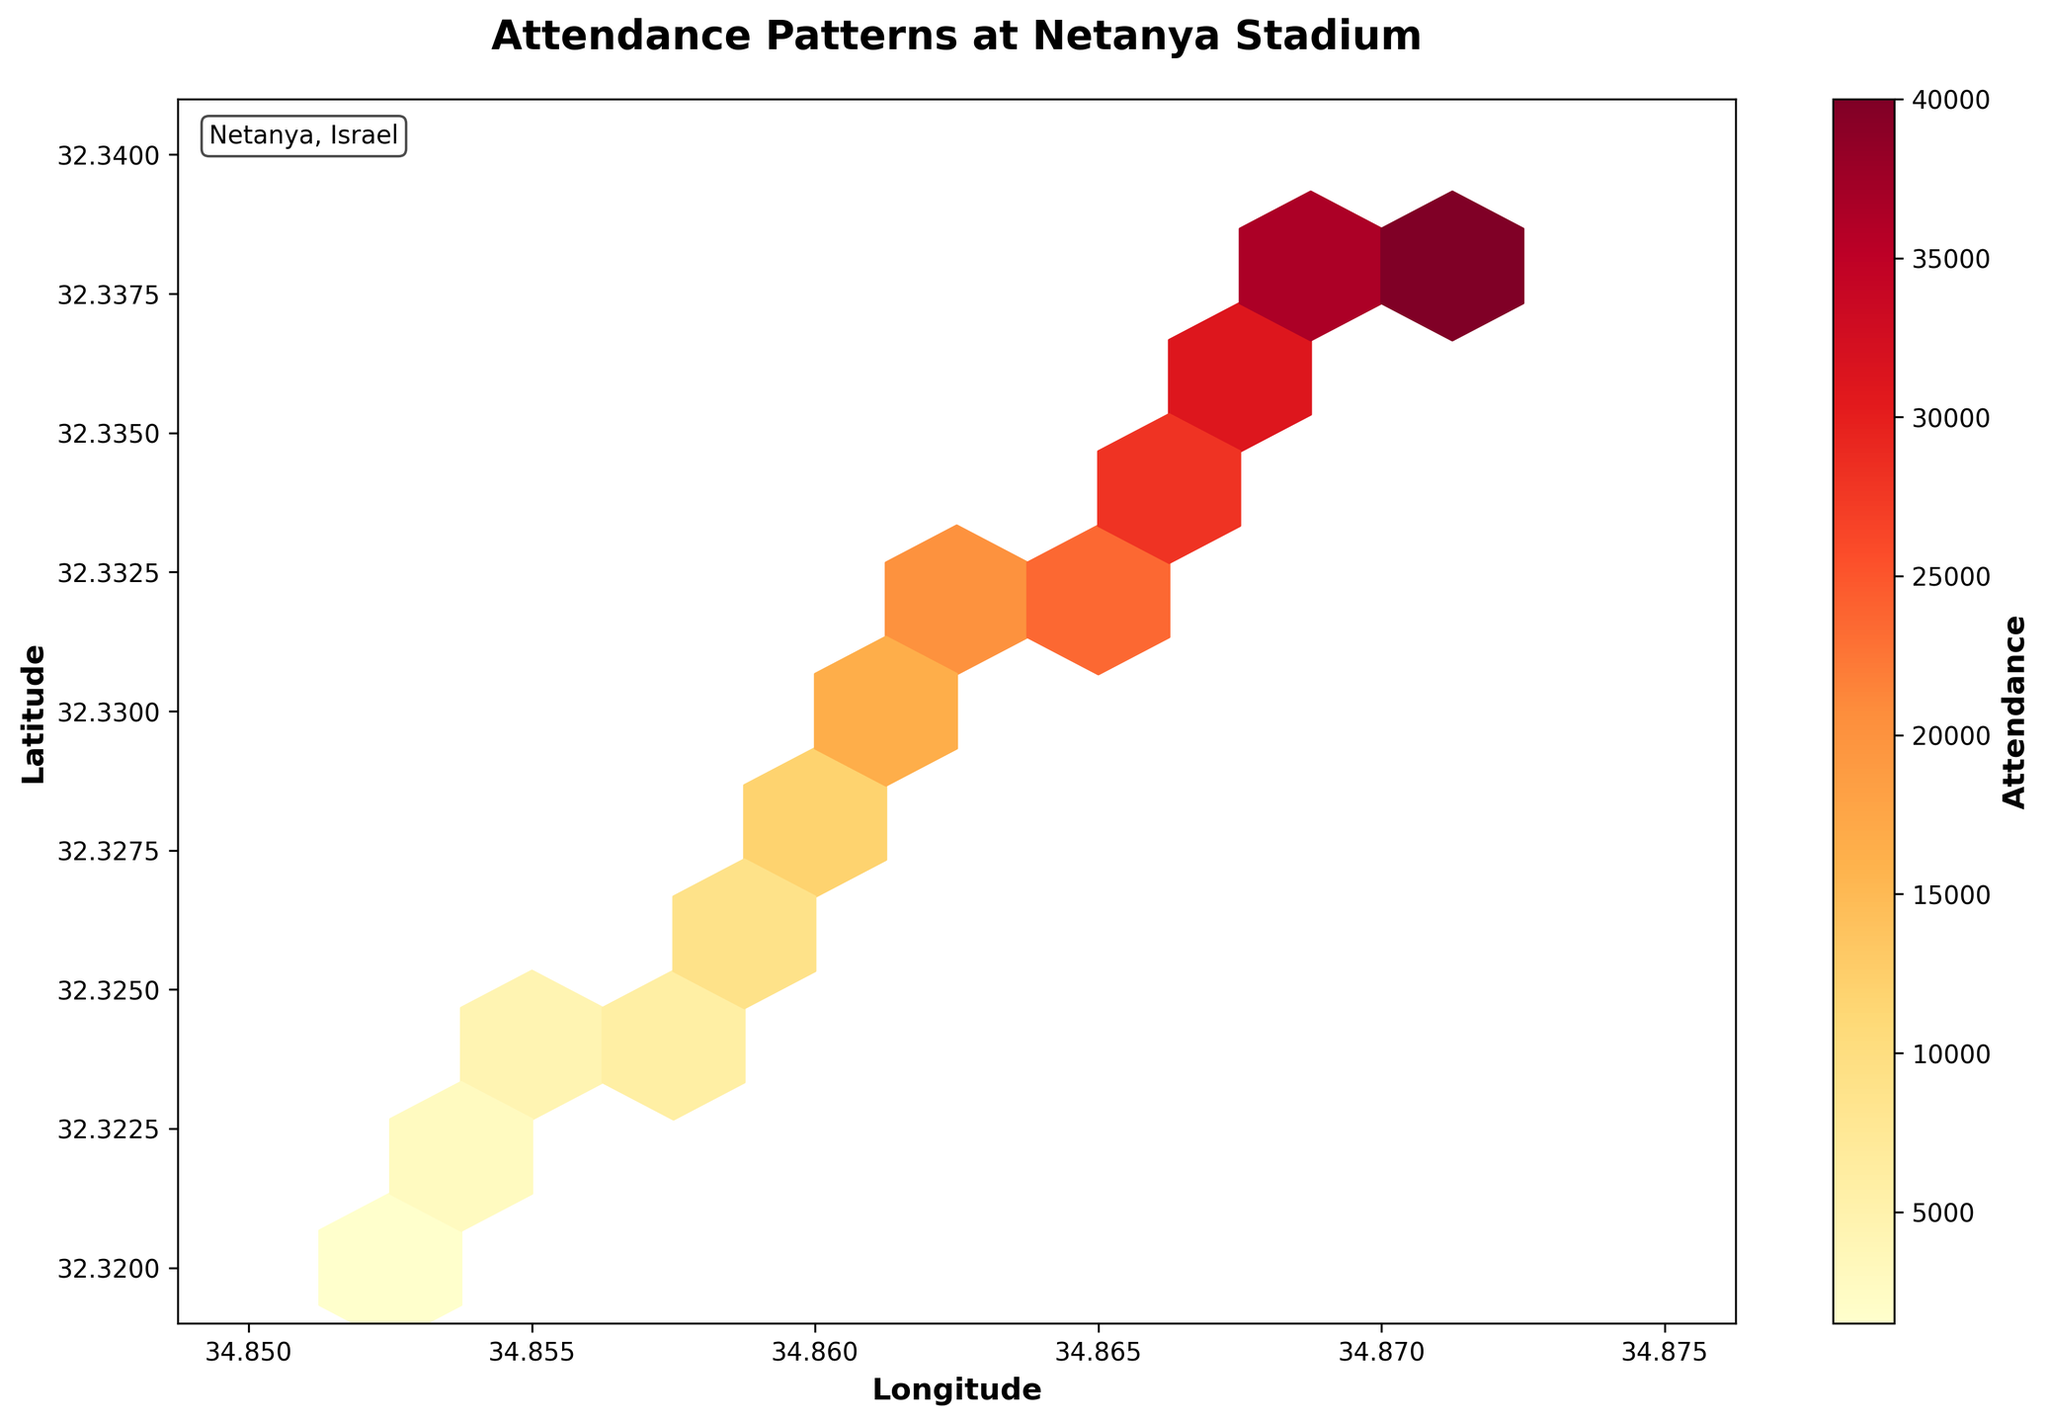What is the title of the figure? The title of a figure is usually found at the top of the plot. In this case, it reads "Attendance Patterns at Netanya Stadium."
Answer: Attendance Patterns at Netanya Stadium What do the colors in the hexagons represent? The color scale of the hexagons indicates the number of attendances, detailed in the color bar labeled "Attendance." Darker colors generally represent higher attendances.
Answer: Number of attendances What are the range values indicated on the color bar? The color bar's range can be read from the values displayed next to it, which show the minimum and maximum attendance values represented by the colors.
Answer: 1000 to 40000 Where is the highest attendance located? The highest attendance can be found by identifying the darkest hexagon, and the tool-tip or grid location can help pinpoint the longitude and latitude coordinates.
Answer: Approximately at (34.871, 32.339) What are the longitude and latitude ranges covered by the plot? The ranges can be deduced from the axis labels. The longitude axis ranges from 34.85 to 34.875, and the latitude axis ranges from 32.32 to 32.34.
Answer: Longitude: 34.85 to 34.875, Latitude: 32.32 to 32.34 How does the attendance level change as we move from the bottom-left to the top-right of the plot? Observing the gradient of hexagon colors from bottom-left to top-right, it can be seen that the colors become darker, indicating an increase in attendance levels.
Answer: Attendance increases Which geographical area within the plot has the lowest attendance? The lightest hexagon, representing the lowest attendance, can be found in the lower-left corner of the plot. This corresponds to a longitude around 34.852 and a latitude of 32.320.
Answer: (34.852, 32.320) Compare the attendance at (34.870, 32.338) and (34.860, 32.328). Which one is higher? Locate the respective hexagons at (34.870, 32.338) and (34.860, 32.328). The darker hexagon represents higher attendance.
Answer: (34.870, 32.338) What could be the reason for regions with lower attendance? The regions with lighter hexagons might indicate less popular sections of the stadium, areas with fewer events, or geographically less accessible locations.
Answer: Less popular/fewer events How many hexagons are present in the plot? The number of hexagons is related to the grid size parameter used, which divides the plotted area into hexagonal bins. Counting the hexagons gives the total number.
Answer: 10 rows x 10 columns = 100 hexagons 